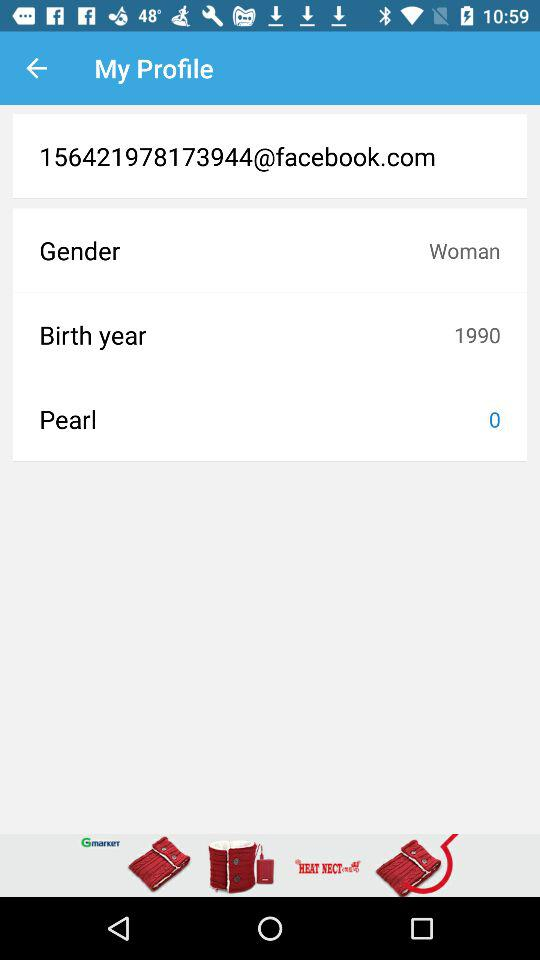What is the gender of the user? The gender of the user is "Woman". 